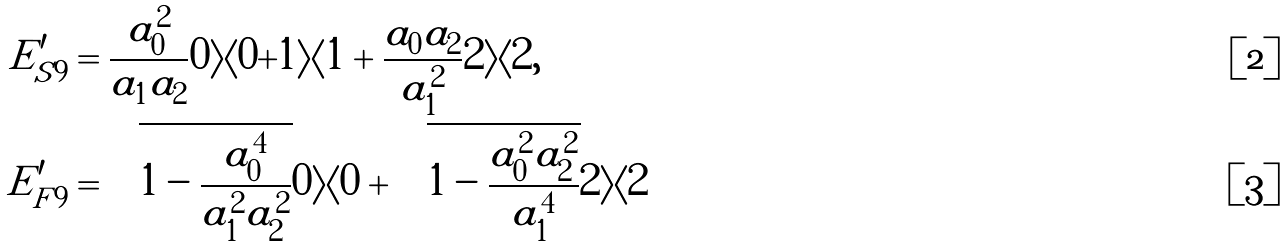<formula> <loc_0><loc_0><loc_500><loc_500>E ^ { \prime } _ { S 9 } & = \frac { a _ { 0 } ^ { 2 } } { a _ { 1 } a _ { 2 } } | 0 \rangle \langle 0 | + | 1 \rangle \langle 1 | + \frac { a _ { 0 } a _ { 2 } } { a _ { 1 } ^ { 2 } } | 2 \rangle \langle 2 | , \\ E ^ { \prime } _ { F 9 } & = \sqrt { 1 - \frac { a _ { 0 } ^ { 4 } } { a _ { 1 } ^ { 2 } a _ { 2 } ^ { 2 } } } | 0 \rangle \langle 0 | + \sqrt { 1 - \frac { a _ { 0 } ^ { 2 } a _ { 2 } ^ { 2 } } { a _ { 1 } ^ { 4 } } } | 2 \rangle \langle 2 |</formula> 